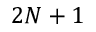Convert formula to latex. <formula><loc_0><loc_0><loc_500><loc_500>2 N + 1</formula> 